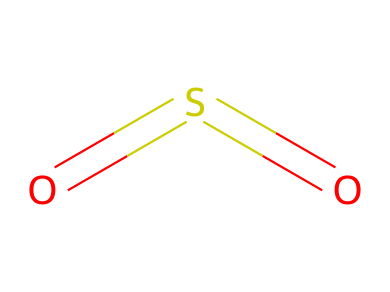What is the molecular formula of this compound? The SMILES representation indicates two oxygen atoms and one sulfur atom, which combines to form the molecular formula, SO2.
Answer: SO2 How many total atoms are present in sulfur dioxide? Counting the sulfur atom and the two oxygen atoms in the chemical structure, there are a total of three atoms.
Answer: 3 What type of bonds are present in this compound? The structure contains double bonds between the sulfur atom and each of the two oxygen atoms, which indicates the presence of double bonds in the chemical.
Answer: double bonds What is the oxidation state of sulfur in this molecule? In SO2, sulfur is typically assigned an oxidation state of +4 due to its bonding with the more electronegative oxygen atoms.
Answer: +4 Why is sulfur dioxide used as a preservative for dried fruits? Sulfur dioxide inhibits microbial growth and prevents oxidation, which helps maintain the color and flavor of dried fruits.
Answer: inhibit microbial growth How many resonance structures can sulfur dioxide have? Sulfur dioxide has two resonance structures due to the arrangement of double bonds between sulfur and oxygen, allowing for different placements of electrons.
Answer: 2 What is the state of sulfur dioxide at room temperature and pressure? At room temperature and pressure, sulfur dioxide is a gas, which is consistent with its physical properties.
Answer: gas 